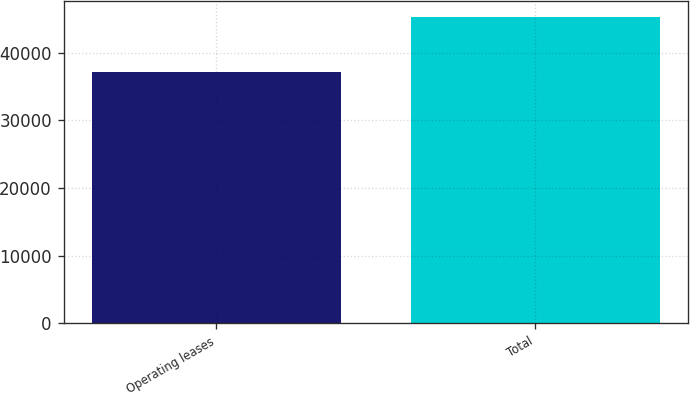Convert chart to OTSL. <chart><loc_0><loc_0><loc_500><loc_500><bar_chart><fcel>Operating leases<fcel>Total<nl><fcel>37148<fcel>45343<nl></chart> 